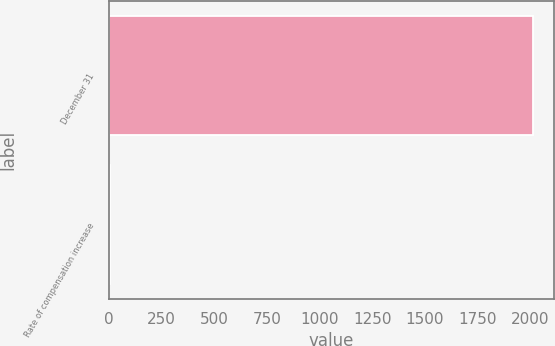Convert chart to OTSL. <chart><loc_0><loc_0><loc_500><loc_500><bar_chart><fcel>December 31<fcel>Rate of compensation increase<nl><fcel>2014<fcel>3.5<nl></chart> 